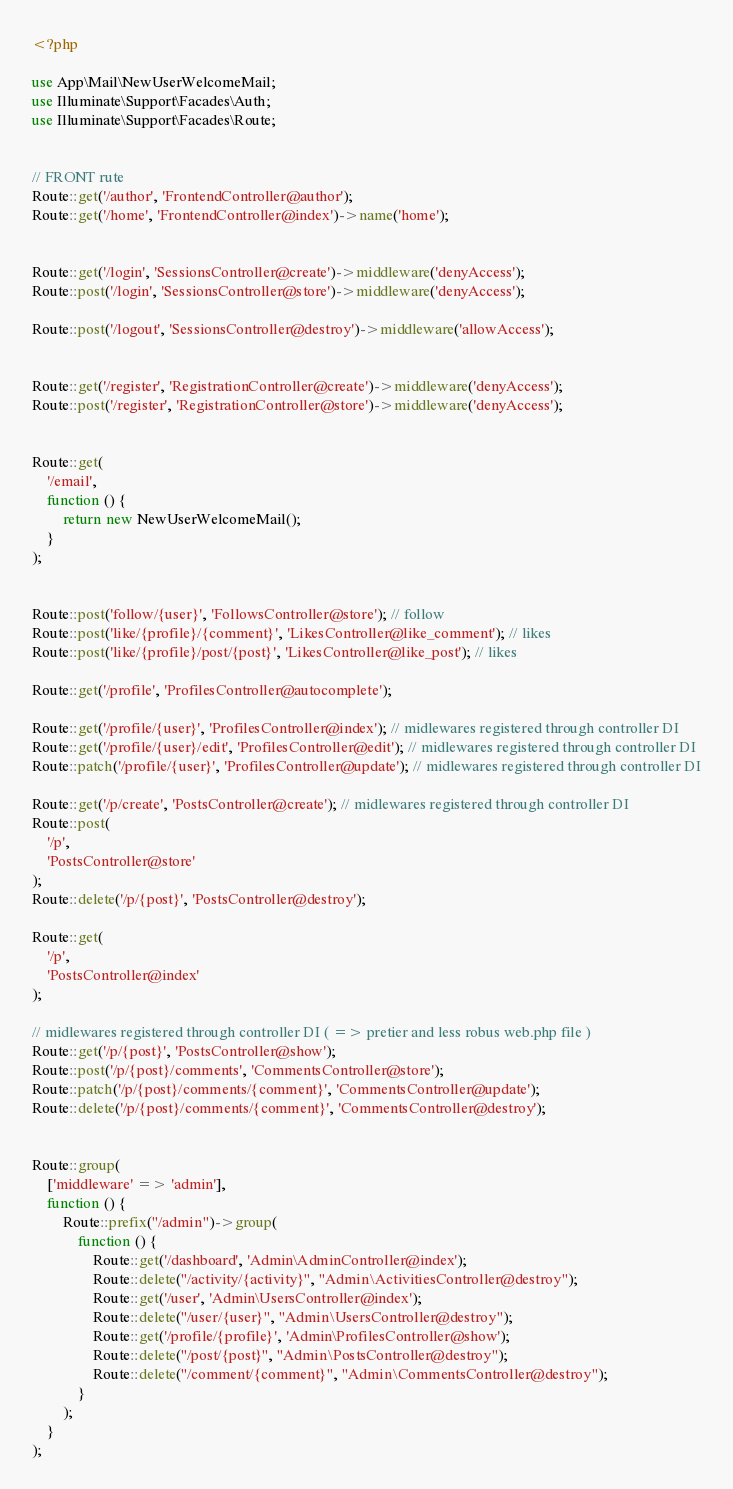Convert code to text. <code><loc_0><loc_0><loc_500><loc_500><_PHP_><?php

use App\Mail\NewUserWelcomeMail;
use Illuminate\Support\Facades\Auth;
use Illuminate\Support\Facades\Route;


// FRONT rute
Route::get('/author', 'FrontendController@author');
Route::get('/home', 'FrontendController@index')->name('home');


Route::get('/login', 'SessionsController@create')->middleware('denyAccess');
Route::post('/login', 'SessionsController@store')->middleware('denyAccess');

Route::post('/logout', 'SessionsController@destroy')->middleware('allowAccess');


Route::get('/register', 'RegistrationController@create')->middleware('denyAccess');
Route::post('/register', 'RegistrationController@store')->middleware('denyAccess');


Route::get(
    '/email',
    function () {
        return new NewUserWelcomeMail();
    }
);


Route::post('follow/{user}', 'FollowsController@store'); // follow
Route::post('like/{profile}/{comment}', 'LikesController@like_comment'); // likes
Route::post('like/{profile}/post/{post}', 'LikesController@like_post'); // likes

Route::get('/profile', 'ProfilesController@autocomplete');

Route::get('/profile/{user}', 'ProfilesController@index'); // midlewares registered through controller DI
Route::get('/profile/{user}/edit', 'ProfilesController@edit'); // midlewares registered through controller DI
Route::patch('/profile/{user}', 'ProfilesController@update'); // midlewares registered through controller DI

Route::get('/p/create', 'PostsController@create'); // midlewares registered through controller DI
Route::post(
    '/p',
    'PostsController@store'
);
Route::delete('/p/{post}', 'PostsController@destroy');

Route::get(
    '/p',
    'PostsController@index'
);

// midlewares registered through controller DI ( => pretier and less robus web.php file )
Route::get('/p/{post}', 'PostsController@show');
Route::post('/p/{post}/comments', 'CommentsController@store');
Route::patch('/p/{post}/comments/{comment}', 'CommentsController@update');
Route::delete('/p/{post}/comments/{comment}', 'CommentsController@destroy');


Route::group(
    ['middleware' => 'admin'],
    function () {
        Route::prefix("/admin")->group(
            function () {
                Route::get('/dashboard', 'Admin\AdminController@index');
                Route::delete("/activity/{activity}", "Admin\ActivitiesController@destroy");
                Route::get('/user', 'Admin\UsersController@index');
                Route::delete("/user/{user}", "Admin\UsersController@destroy");
                Route::get('/profile/{profile}', 'Admin\ProfilesController@show');
                Route::delete("/post/{post}", "Admin\PostsController@destroy");
                Route::delete("/comment/{comment}", "Admin\CommentsController@destroy");
            }
        );
    }
);
</code> 